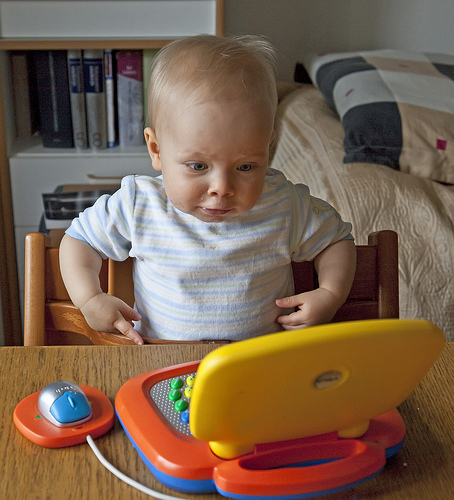<image>
Is the child in the bed? No. The child is not contained within the bed. These objects have a different spatial relationship. 